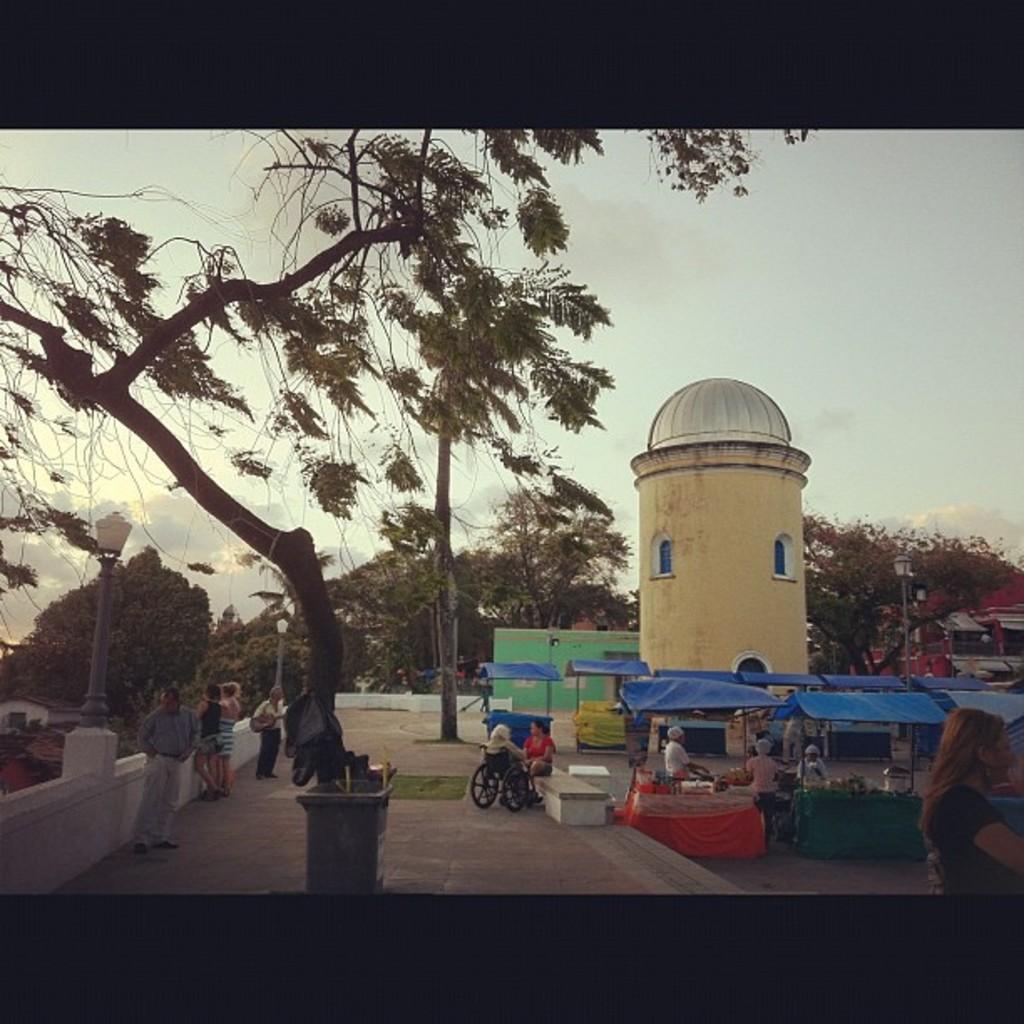In one or two sentences, can you explain what this image depicts? In this image in the center there is a tree. In the background there are trees and there is a monument and there are tents and the persons are sitting and standing and there are light poles and the sky is cloudy. 